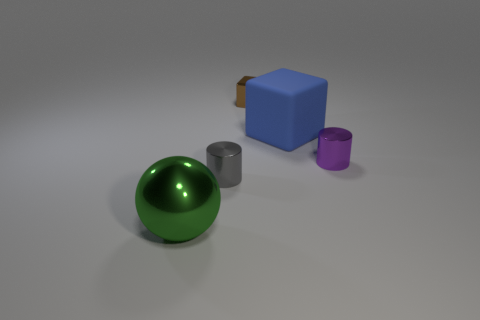Subtract all balls. How many objects are left? 4 Add 3 rubber cubes. How many objects exist? 8 Subtract all brown cylinders. Subtract all large things. How many objects are left? 3 Add 5 blue blocks. How many blue blocks are left? 6 Add 3 tiny gray cylinders. How many tiny gray cylinders exist? 4 Subtract 0 purple blocks. How many objects are left? 5 